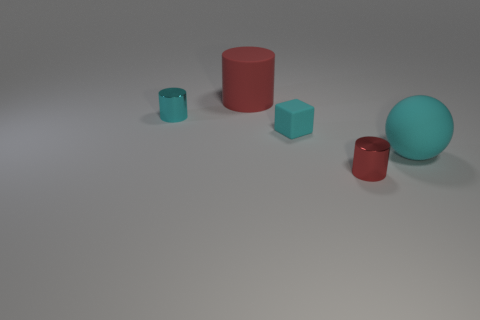Add 2 big rubber things. How many objects exist? 7 Subtract all blocks. How many objects are left? 4 Add 1 cyan metallic cylinders. How many cyan metallic cylinders exist? 2 Subtract 0 gray cylinders. How many objects are left? 5 Subtract all gray cylinders. Subtract all cyan metallic objects. How many objects are left? 4 Add 2 large cyan objects. How many large cyan objects are left? 3 